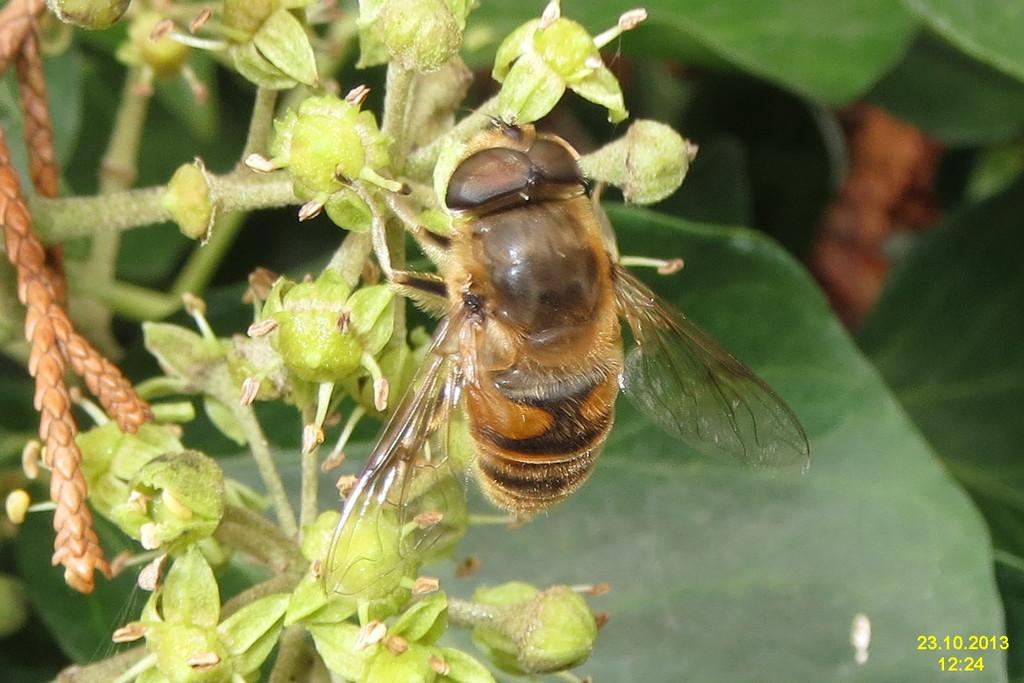What type of creature can be seen in the image? There is an insect in the image. Where is the insect located in the image? The insect is on one of the plants. What type of leather can be seen in the image? There is no leather present in the image; it features an insect on a plant. 